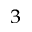<formula> <loc_0><loc_0><loc_500><loc_500>^ { 3 }</formula> 